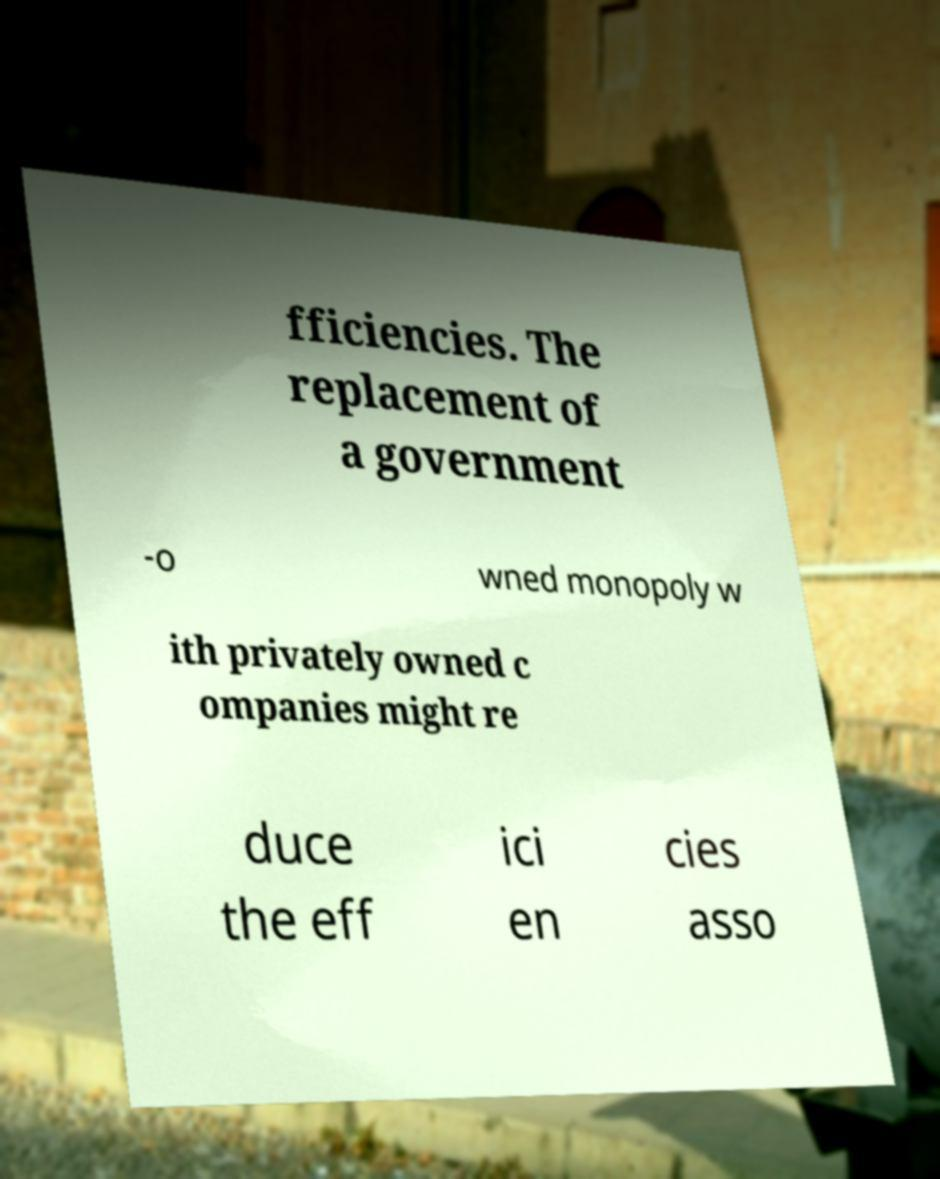What messages or text are displayed in this image? I need them in a readable, typed format. fficiencies. The replacement of a government -o wned monopoly w ith privately owned c ompanies might re duce the eff ici en cies asso 